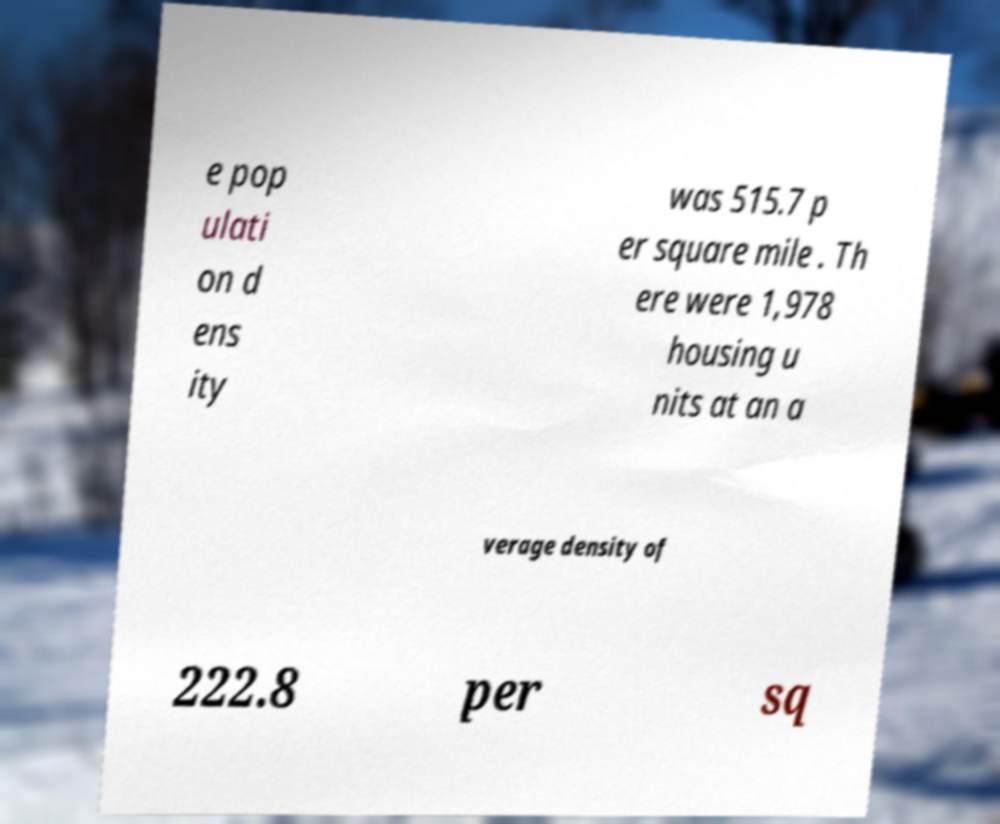Could you extract and type out the text from this image? e pop ulati on d ens ity was 515.7 p er square mile . Th ere were 1,978 housing u nits at an a verage density of 222.8 per sq 